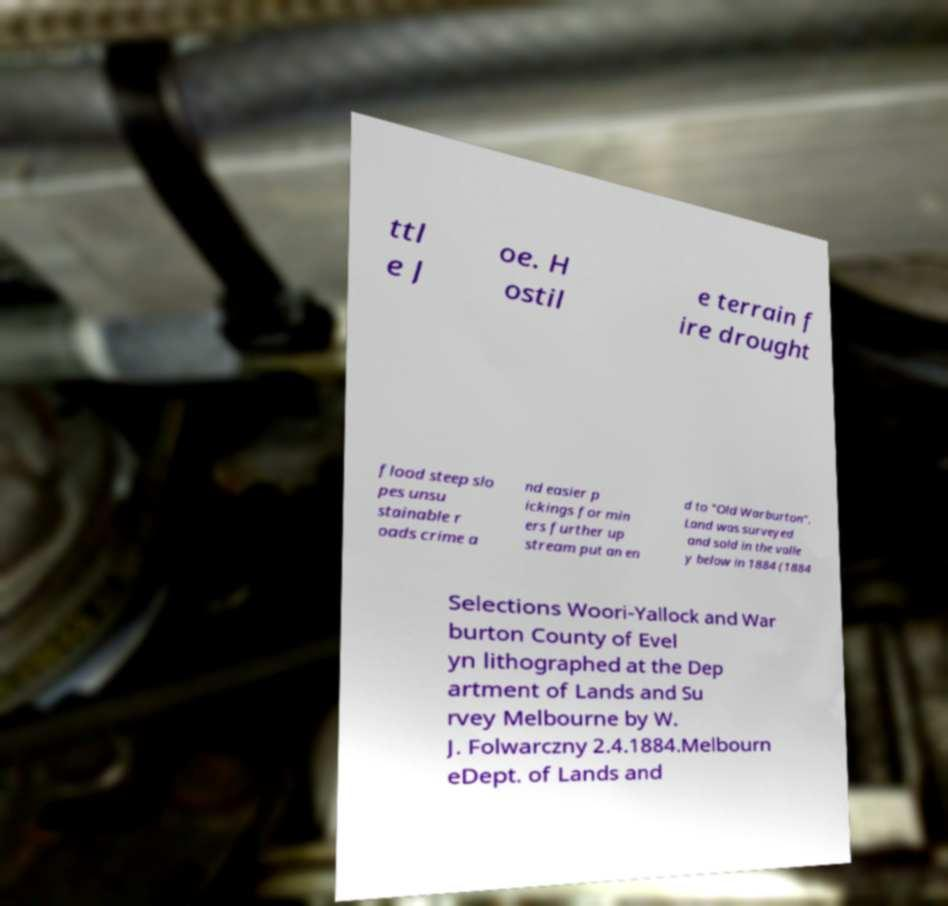Can you read and provide the text displayed in the image?This photo seems to have some interesting text. Can you extract and type it out for me? ttl e J oe. H ostil e terrain f ire drought flood steep slo pes unsu stainable r oads crime a nd easier p ickings for min ers further up stream put an en d to "Old Warburton". Land was surveyed and sold in the valle y below in 1884 (1884 Selections Woori-Yallock and War burton County of Evel yn lithographed at the Dep artment of Lands and Su rvey Melbourne by W. J. Folwarczny 2.4.1884.Melbourn eDept. of Lands and 